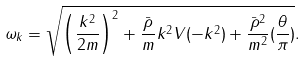Convert formula to latex. <formula><loc_0><loc_0><loc_500><loc_500>\omega _ { k } = \sqrt { \left ( \frac { { k } ^ { 2 } } { 2 m } \right ) ^ { 2 } + \frac { \bar { \rho } } { m } { k } ^ { 2 } V ( - { k } ^ { 2 } ) + \frac { \bar { \rho } ^ { 2 } } { m ^ { 2 } } ( \frac { \theta } { \pi } ) } .</formula> 